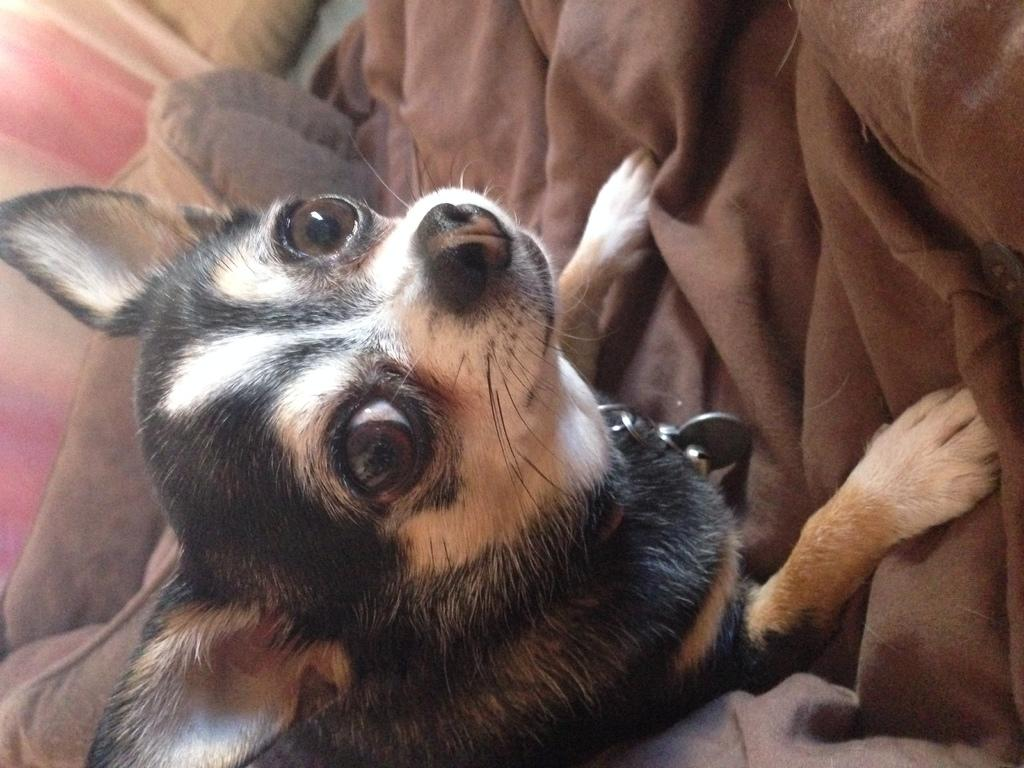What type of animal is present in the image? There is a dog in the image. Where is the dog located in the image? The dog is on a couch. What type of liquid is the dog playing with on the playground in the image? There is no liquid or playground present in the image; it features a dog on a couch. What type of rice is visible in the image? There is no rice present in the image. 